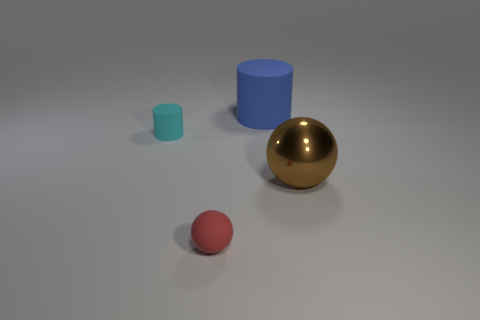There is a thing that is both on the right side of the tiny sphere and on the left side of the metallic ball; what is its size?
Provide a succinct answer. Large. What is the size of the object that is in front of the large thing right of the rubber cylinder to the right of the cyan rubber cylinder?
Your answer should be compact. Small. What number of other objects are the same color as the large ball?
Keep it short and to the point. 0. There is a big object that is on the left side of the big brown shiny thing; is its color the same as the large sphere?
Make the answer very short. No. What number of objects are tiny blue things or spheres?
Offer a very short reply. 2. What color is the small matte thing that is behind the large brown thing?
Offer a terse response. Cyan. Is the number of large things in front of the small red matte object less than the number of small cyan matte cylinders?
Keep it short and to the point. Yes. Is there any other thing that has the same size as the brown object?
Give a very brief answer. Yes. Is the material of the tiny red thing the same as the big ball?
Offer a terse response. No. What number of objects are either large things to the left of the shiny sphere or small things that are in front of the cyan rubber cylinder?
Provide a succinct answer. 2. 